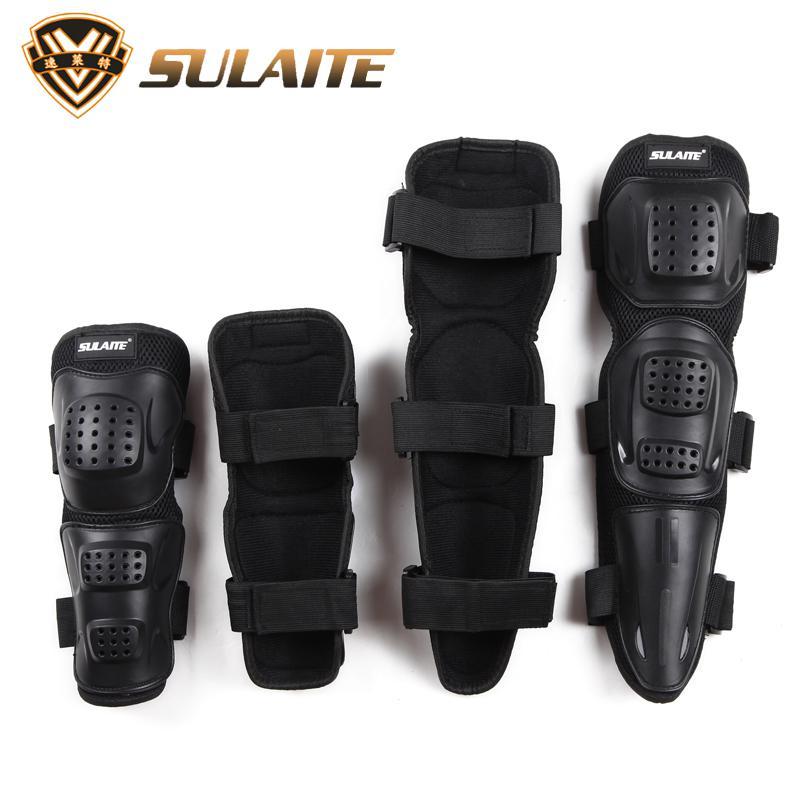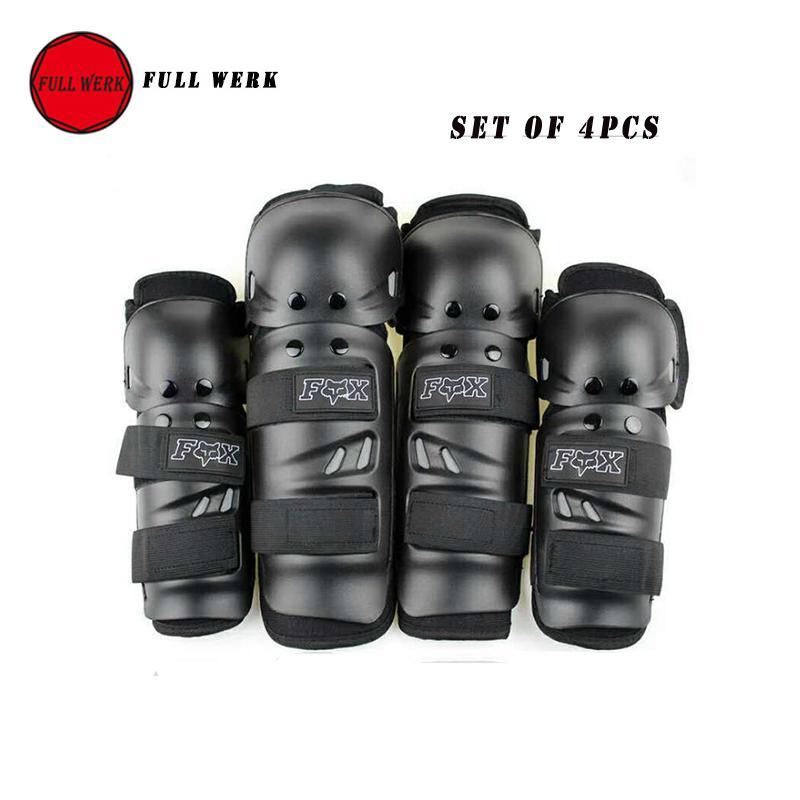The first image is the image on the left, the second image is the image on the right. Assess this claim about the two images: "Exactly eight pieces of equipment are shown in groups of four each.". Correct or not? Answer yes or no. Yes. The first image is the image on the left, the second image is the image on the right. Considering the images on both sides, is "One image contains just one pair of black knee pads." valid? Answer yes or no. No. 